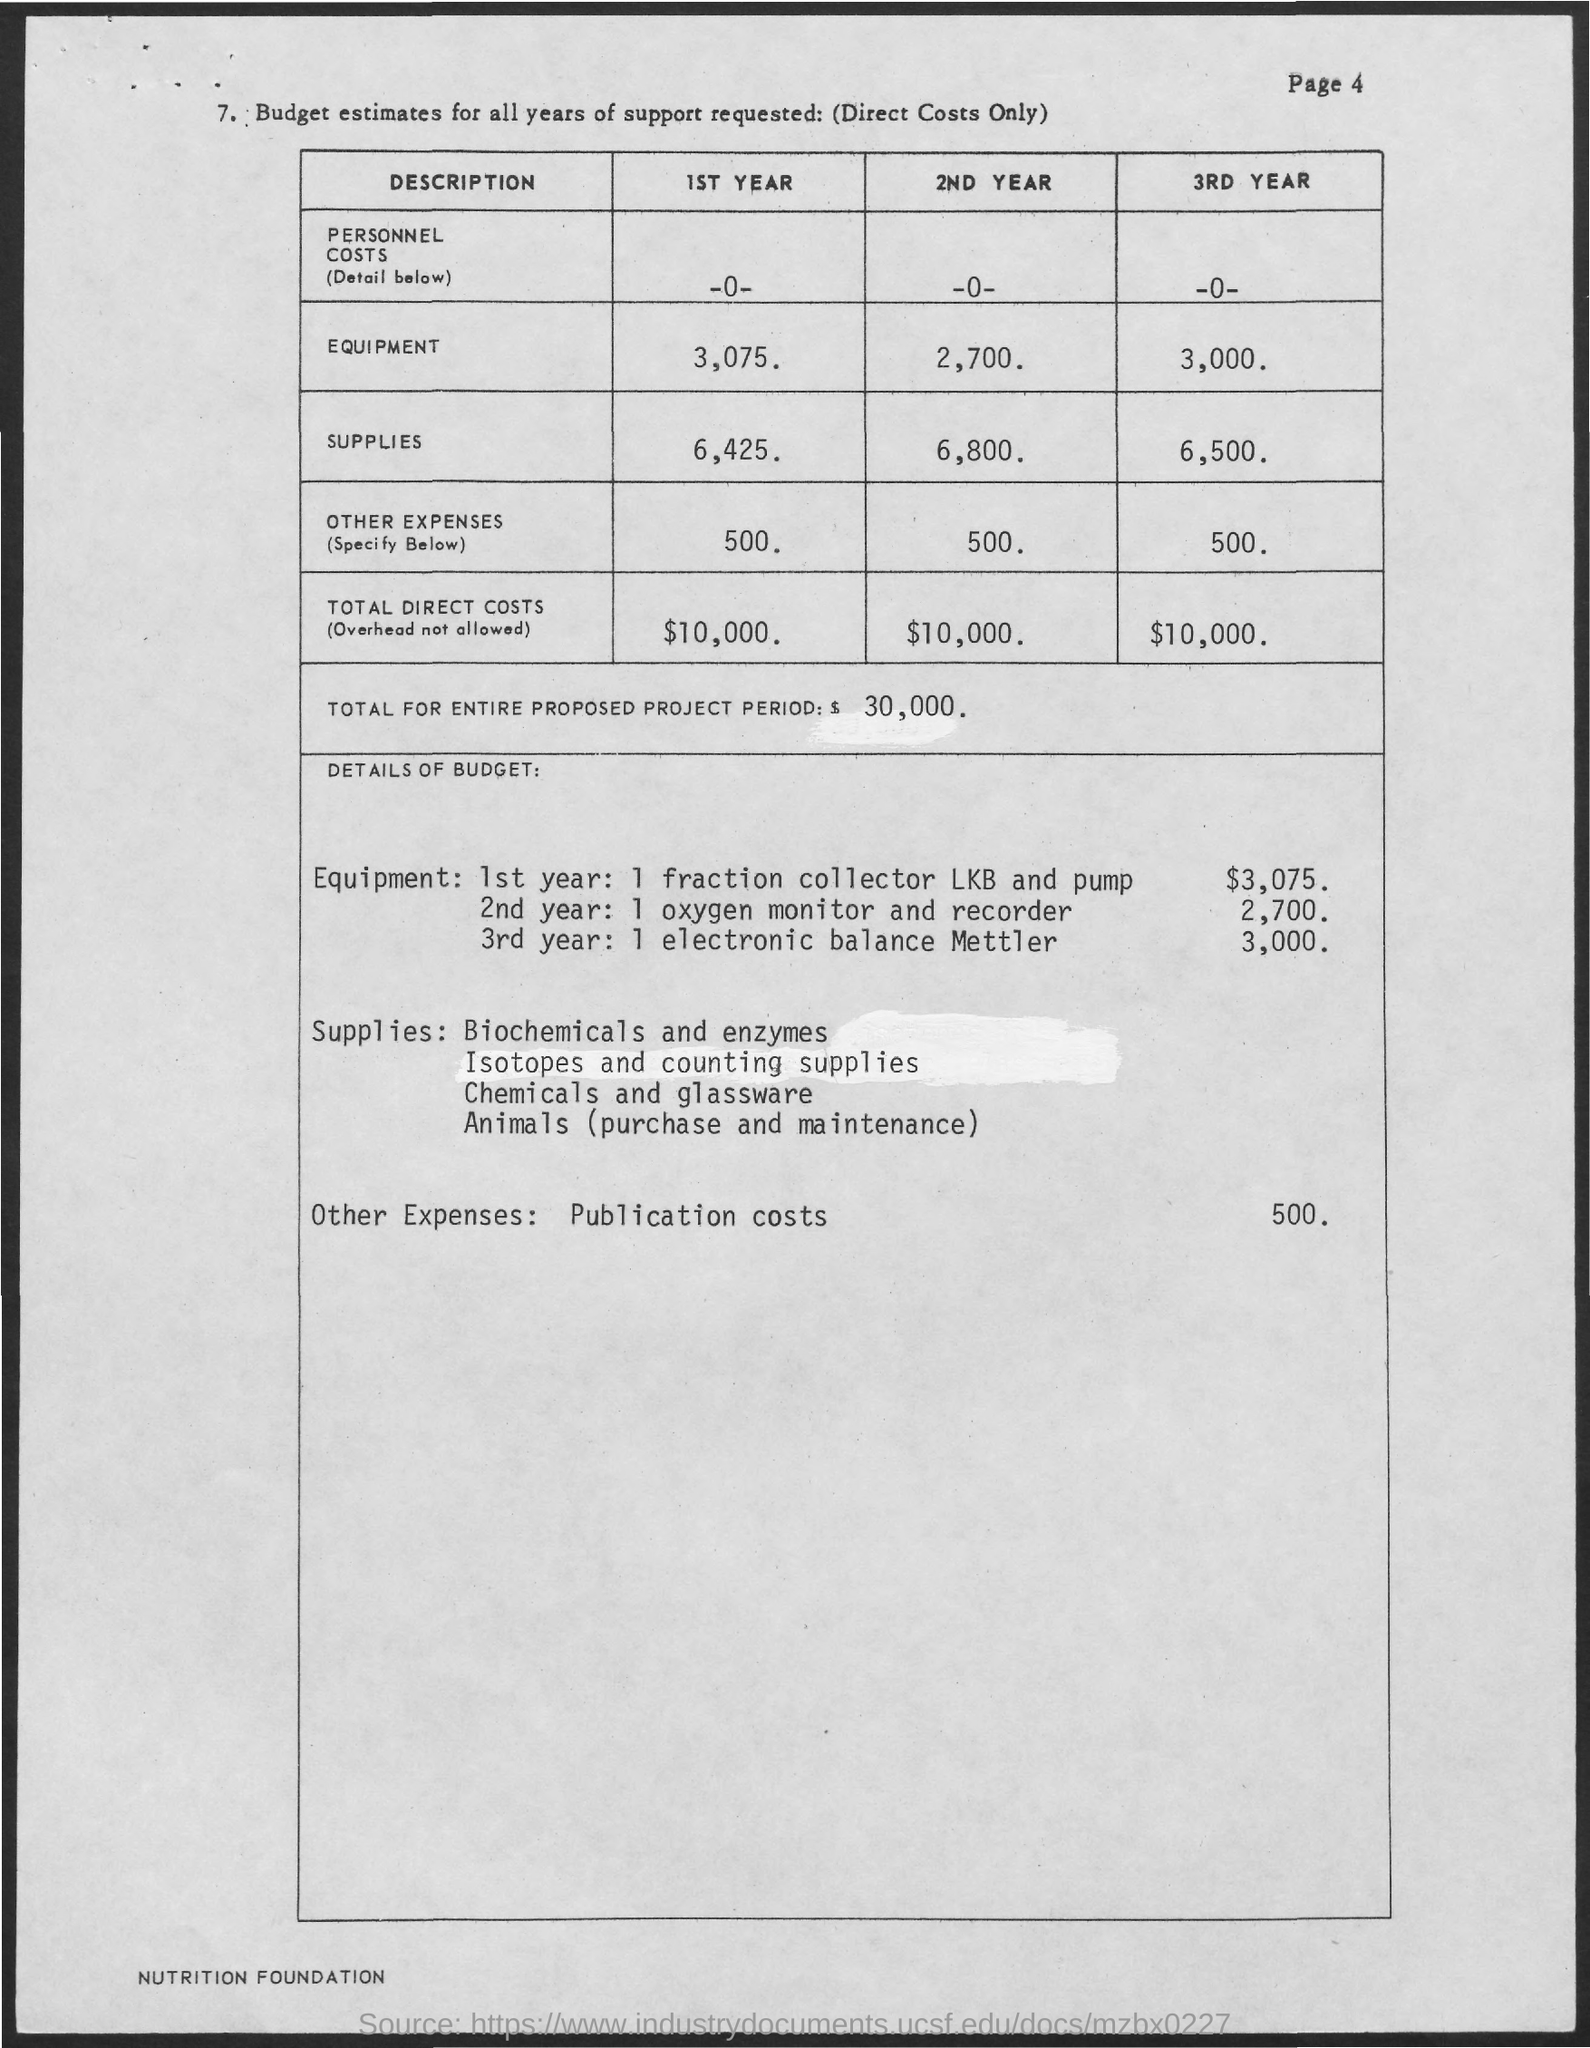Indicate a few pertinent items in this graphic. The estimated budget for supplies in the first year is 6,425. The total direct costs in the third year are estimated to be $10,000. The estimated budget for equipment in the first year is 3,075. The estimated budget for supplies in the second year is approximately $6,800. The total direct costs in the first year are estimated to be $10,000. 